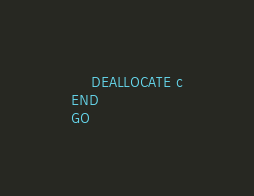<code> <loc_0><loc_0><loc_500><loc_500><_SQL_>    DEALLOCATE c
END
GO</code> 